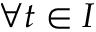Convert formula to latex. <formula><loc_0><loc_0><loc_500><loc_500>\forall t \in I</formula> 